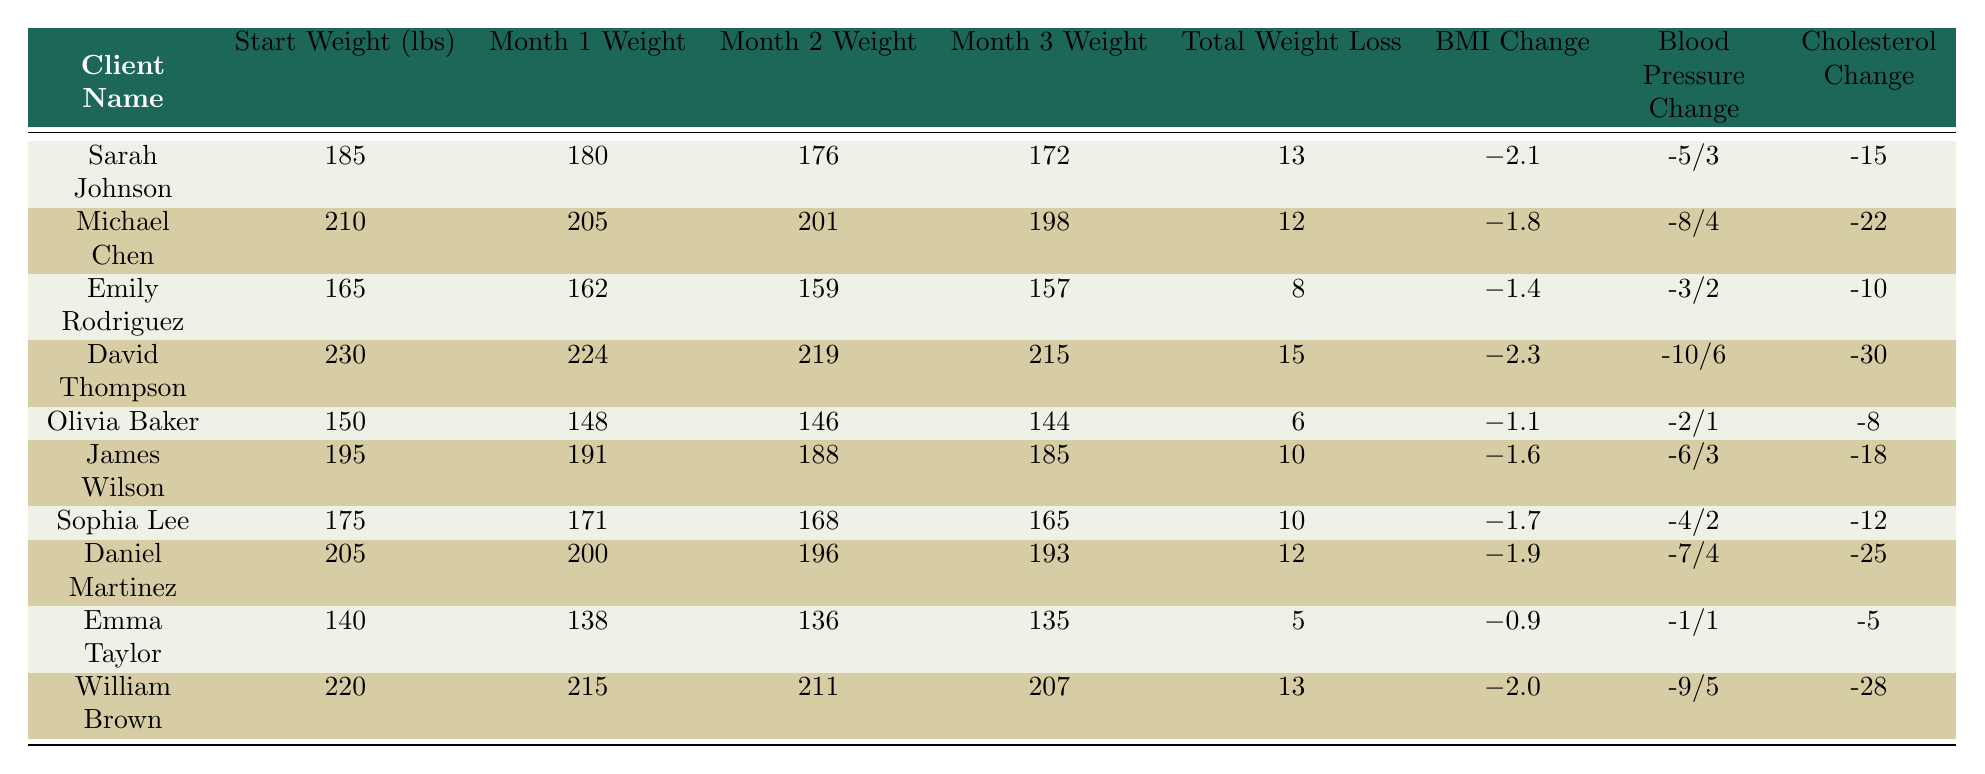What is Sarah Johnson's total weight loss? In the table, Sarah Johnson's total weight loss is listed under the "Total Weight Loss" column. It shows a value of 13.
Answer: 13 How much did Olivia Baker weigh at the start? The "Start Weight (lbs)" column for Olivia Baker shows a value of 150, indicating her initial weight.
Answer: 150 Did any client lose more than 15 pounds? To determine this, I look at the "Total Weight Loss" column. David Thompson lost 15 pounds, which is the maximum loss listed. Thus, no client lost more than 15 pounds.
Answer: No What is the average weight loss for all clients? First, I sum the total weight loss for all clients: 13 + 12 + 8 + 15 + 6 + 10 + 10 + 12 + 5 + 13 = 114. There are 10 clients, so the average weight loss is 114 / 10 = 11.4.
Answer: 11.4 Which client had the highest BMI change? Looking at the column for BMI Change, David Thompson shows a change of -2.3. By comparing all values in this column, we find this is the largest change.
Answer: David Thompson What is the combined cholesterol change for Sarah Johnson and Michael Chen? I look at the "Cholesterol Change" column for both clients. Sarah Johnson's change is -15 and Michael Chen's is -22. Summing these gives -15 + (-22) = -37.
Answer: -37 Which client had the lowest weight after 3 months? The "Month 3 Weight" column indicates that Emma Taylor weighed 135 pounds, which is the lowest weight listed after 3 months, compared to other clients.
Answer: Emma Taylor Is it true that James Wilson had a blood pressure change of -6/3? I can verify this by checking the "Blood Pressure Change" column for James Wilson, which indeed shows a change of -6/3, confirming this statement is true.
Answer: Yes What is the difference in total weight loss between David Thompson and Emma Taylor? David Thompson's total weight loss is 15 pounds, and Emma Taylor's is 5 pounds. To find the difference, I subtract: 15 - 5 = 10.
Answer: 10 